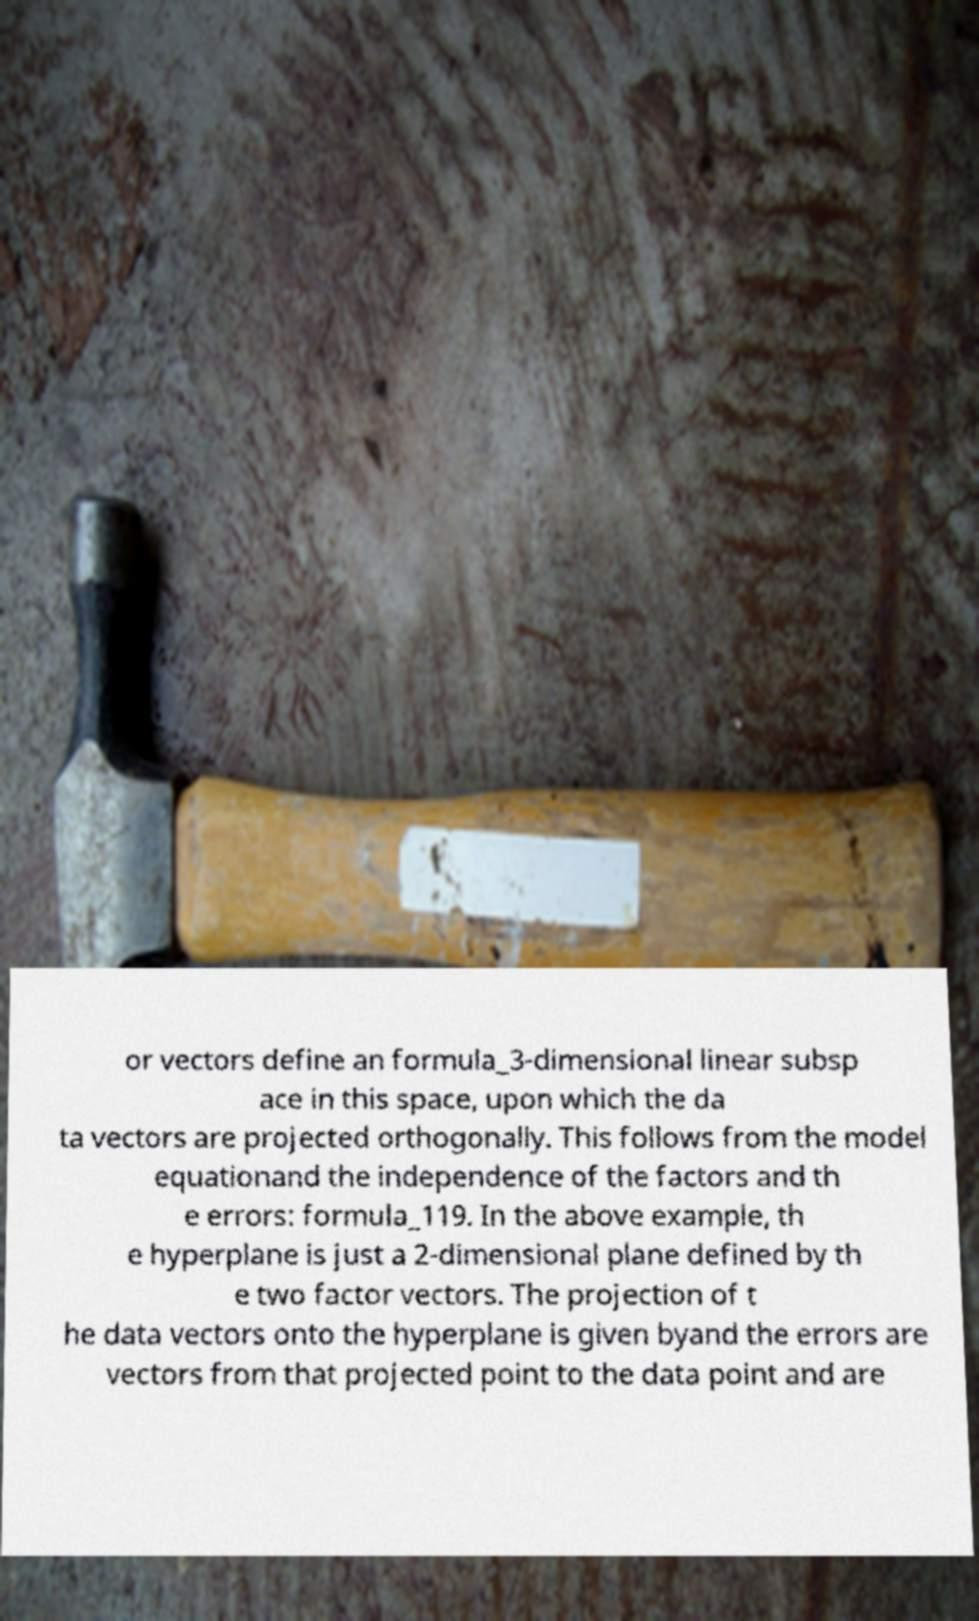Please identify and transcribe the text found in this image. or vectors define an formula_3-dimensional linear subsp ace in this space, upon which the da ta vectors are projected orthogonally. This follows from the model equationand the independence of the factors and th e errors: formula_119. In the above example, th e hyperplane is just a 2-dimensional plane defined by th e two factor vectors. The projection of t he data vectors onto the hyperplane is given byand the errors are vectors from that projected point to the data point and are 